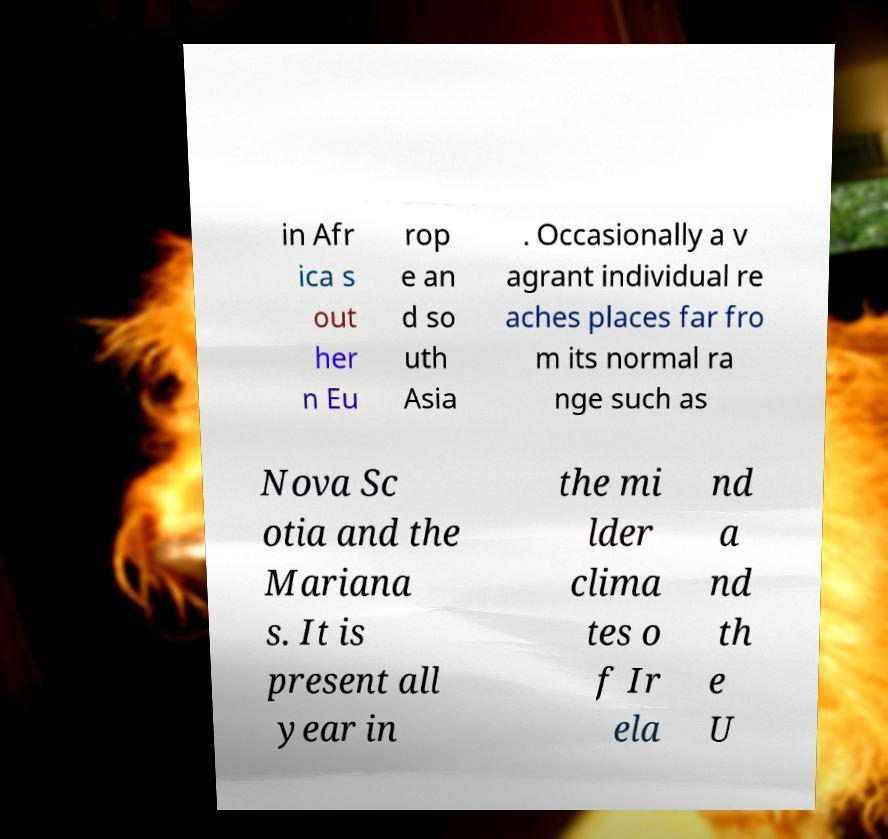I need the written content from this picture converted into text. Can you do that? in Afr ica s out her n Eu rop e an d so uth Asia . Occasionally a v agrant individual re aches places far fro m its normal ra nge such as Nova Sc otia and the Mariana s. It is present all year in the mi lder clima tes o f Ir ela nd a nd th e U 